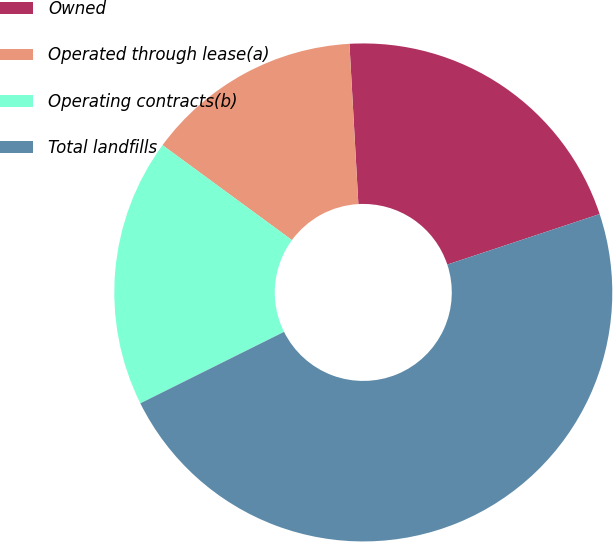Convert chart. <chart><loc_0><loc_0><loc_500><loc_500><pie_chart><fcel>Owned<fcel>Operated through lease(a)<fcel>Operating contracts(b)<fcel>Total landfills<nl><fcel>20.79%<fcel>14.04%<fcel>17.42%<fcel>47.75%<nl></chart> 